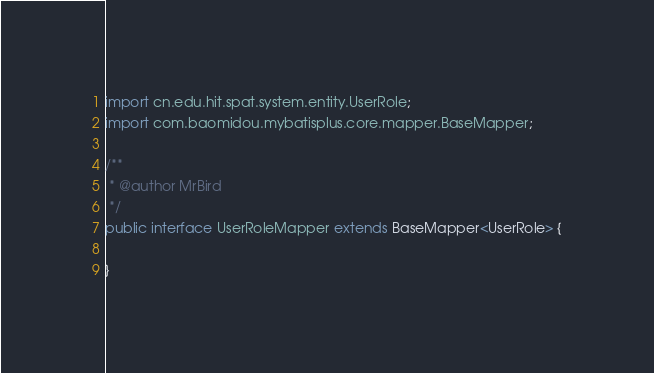Convert code to text. <code><loc_0><loc_0><loc_500><loc_500><_Java_>
import cn.edu.hit.spat.system.entity.UserRole;
import com.baomidou.mybatisplus.core.mapper.BaseMapper;

/**
 * @author MrBird
 */
public interface UserRoleMapper extends BaseMapper<UserRole> {

}
</code> 